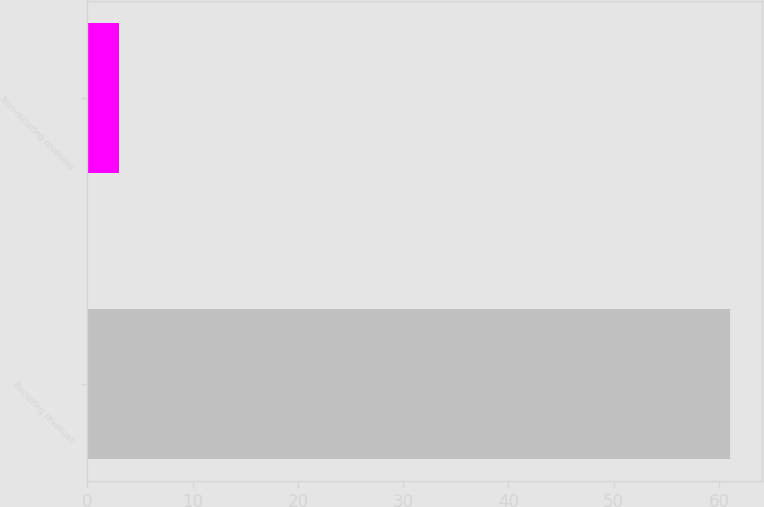Convert chart. <chart><loc_0><loc_0><loc_500><loc_500><bar_chart><fcel>Recurring revenues<fcel>Non-recurring revenues<nl><fcel>61<fcel>3<nl></chart> 